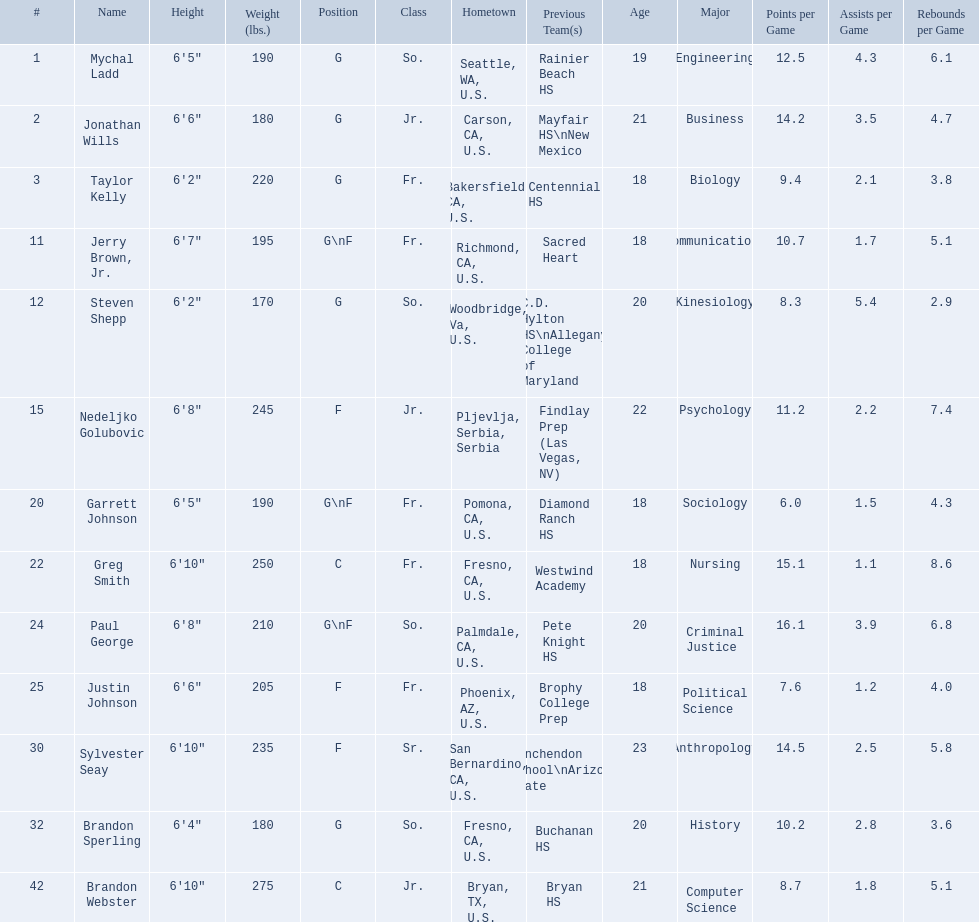Which players are forwards? Nedeljko Golubovic, Paul George, Justin Johnson, Sylvester Seay. What are the heights of these players? Nedeljko Golubovic, 6'8", Paul George, 6'8", Justin Johnson, 6'6", Sylvester Seay, 6'10". Of these players, who is the shortest? Justin Johnson. 